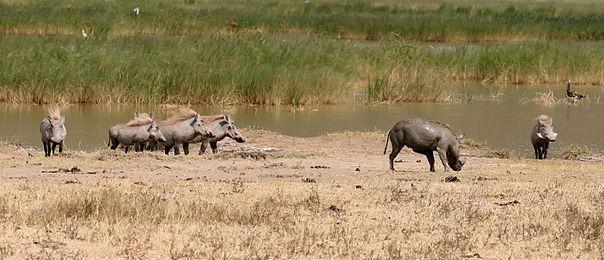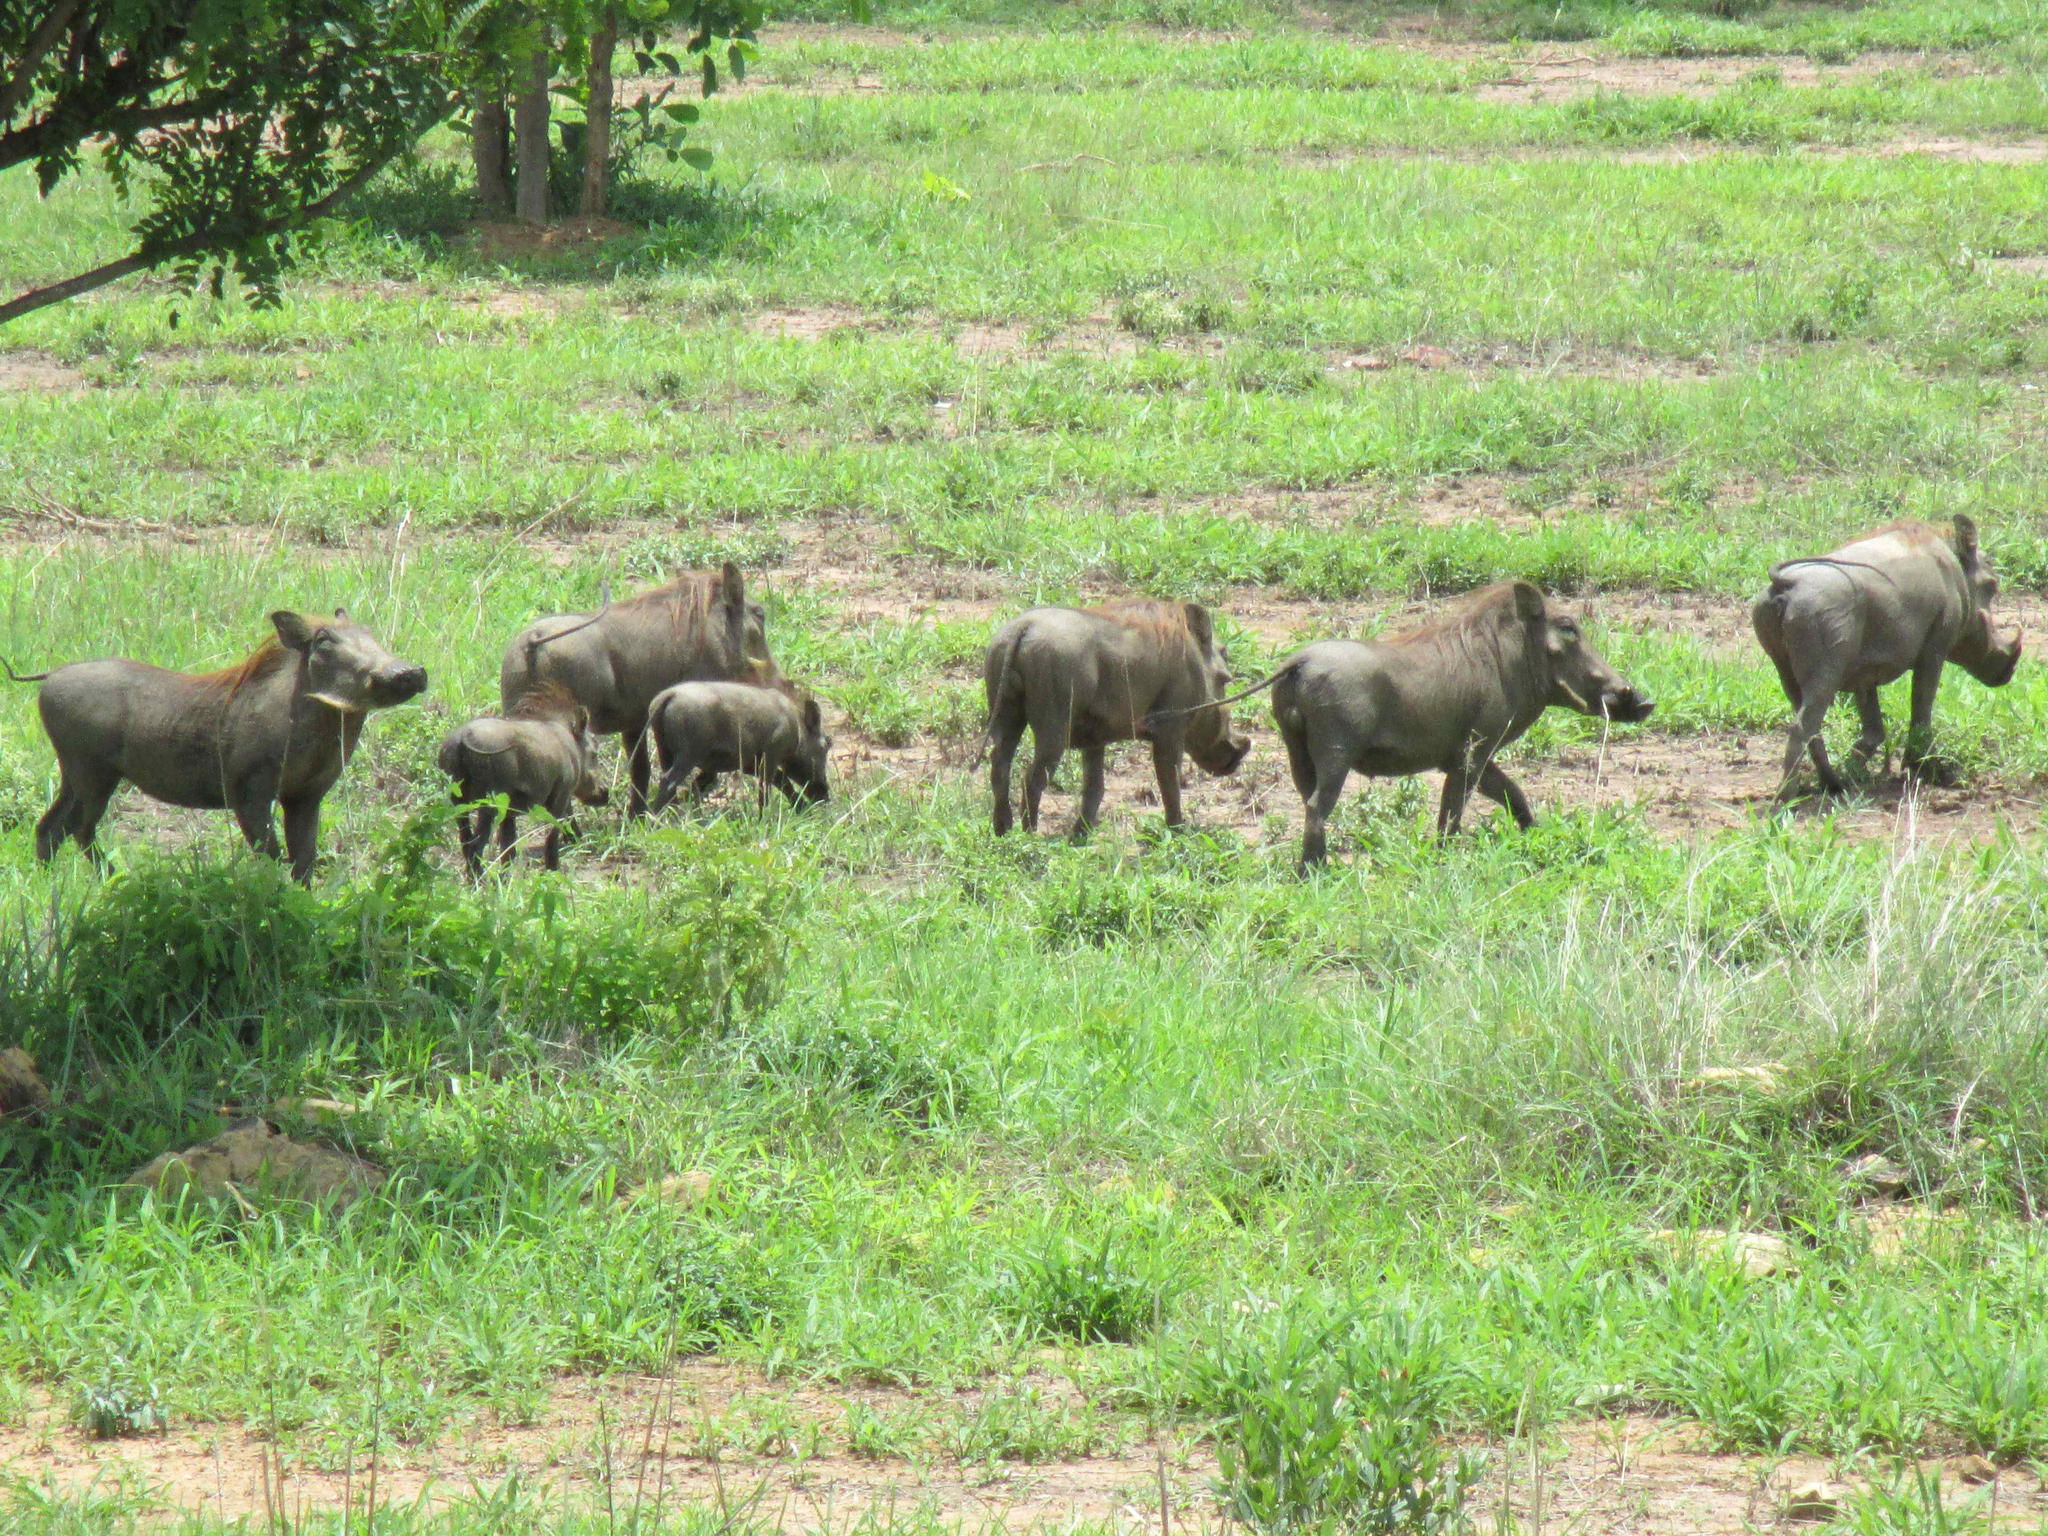The first image is the image on the left, the second image is the image on the right. Given the left and right images, does the statement "An image includes at least five zebra standing on grass behind a patch of dirt." hold true? Answer yes or no. No. The first image is the image on the left, the second image is the image on the right. For the images displayed, is the sentence "Some of the animals are near a watery area." factually correct? Answer yes or no. Yes. 